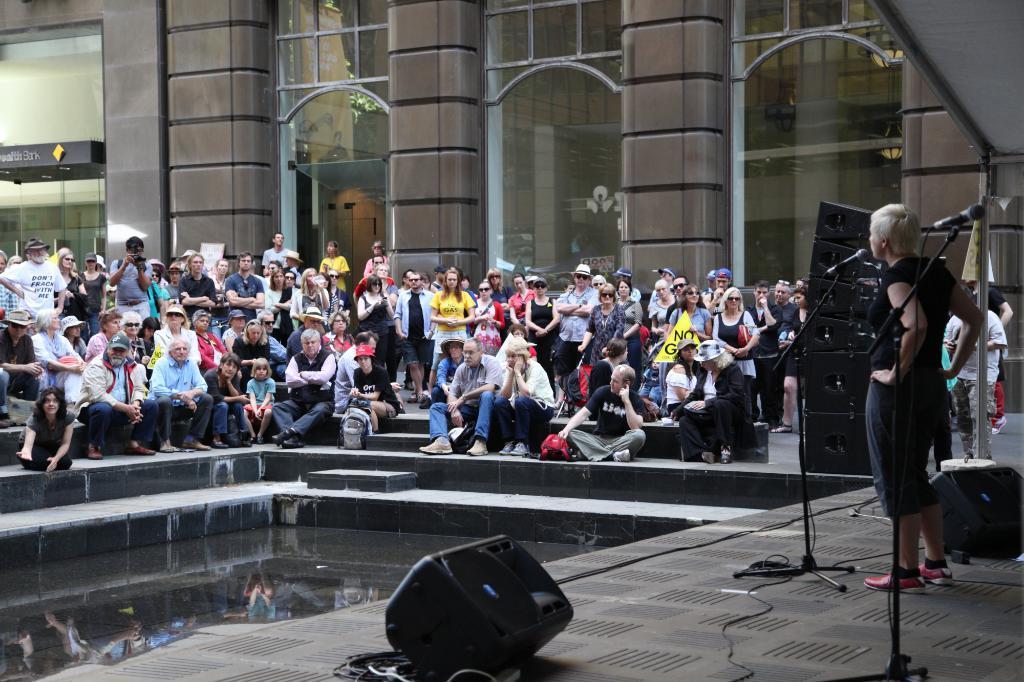Please provide a concise description of this image. This is looking like a stage. Here I can see a person is standing. In front of this person there is a mike stand and I can see some speakers on the floor. On the left side there are some water and stairs. On the top of it I can see few people are sitting and few people standing. Everyone are looking at this person. In the background, I can see a building. 